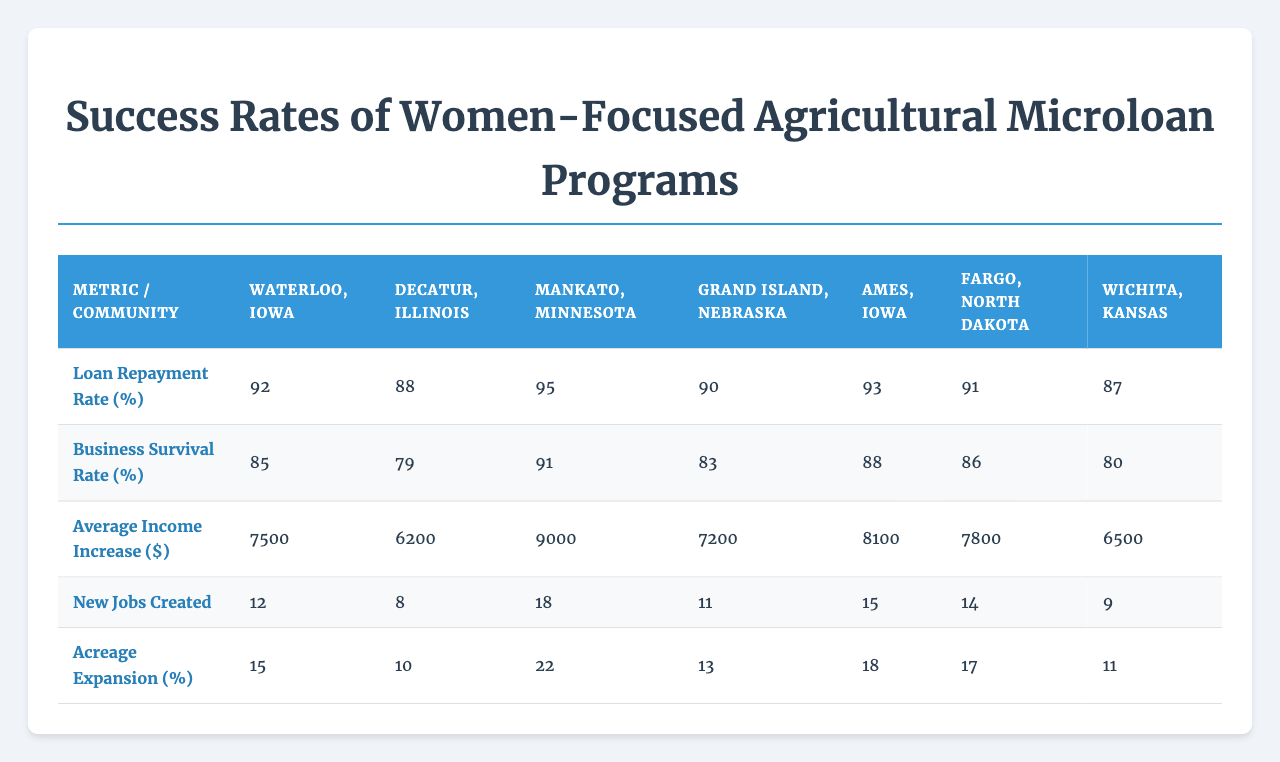What is the loan repayment rate in Mankato, Minnesota? The loan repayment rate for Mankato, Minnesota is provided in the table, which states it is 95%.
Answer: 95% Which community has the highest average income increase? The table indicates that Mankato, Minnesota has the highest average income increase at $9,000.
Answer: $9,000 What is the business survival rate in Waterloo, Iowa? The business survival rate for Waterloo, Iowa is recorded in the table as 85%.
Answer: 85% Among the listed communities, which has the lowest acreage expansion percentage? By comparing the acreage expansion percentages for each community, Wichita, Kansas has the lowest at 11%.
Answer: 11% Is there a community where the loan repayment rate is below 90%? By examining the loan repayment rates, Decatur, Illinois (88%) and Wichita, Kansas (87%) have rates below 90%.
Answer: Yes How many new jobs were created in Fargo, North Dakota? The table specifies that Fargo, North Dakota created 14 new jobs.
Answer: 14 What is the difference in average income increase between Mankato, Minnesota and Decatur, Illinois? Mankato has an average income increase of $9,000 and Decatur has $6,200. The difference is $9,000 - $6,200 = $2,800.
Answer: $2,800 Which community has a business survival rate greater than 85%? By checking the table, Mankato (91%), Ames (88%), and Fargo (86%) have business survival rates greater than 85%.
Answer: Mankato, Ames, Fargo If we consider the average loan repayment rate across all communities, what is it? To find the average, add the loan repayment rates (92 + 88 + 95 + 90 + 93 + 91 + 87 = 616) and divide by the number of communities (7). The average is 616 / 7 = 88. Otherwise, the calculation will result in a total of average loan repayment rate is 88%.
Answer: 88% Which community shows both the highest business survival rate and job creation? Mankato, Minnesota has the highest business survival rate (91%) and created the most new jobs (18), making it the community with both the highest rates.
Answer: Mankato, Minnesota What percentage of acreage expansion does Grand Island, Nebraska have? The table lists Grand Island, Nebraska's acreage expansion percentage as 13%.
Answer: 13% 